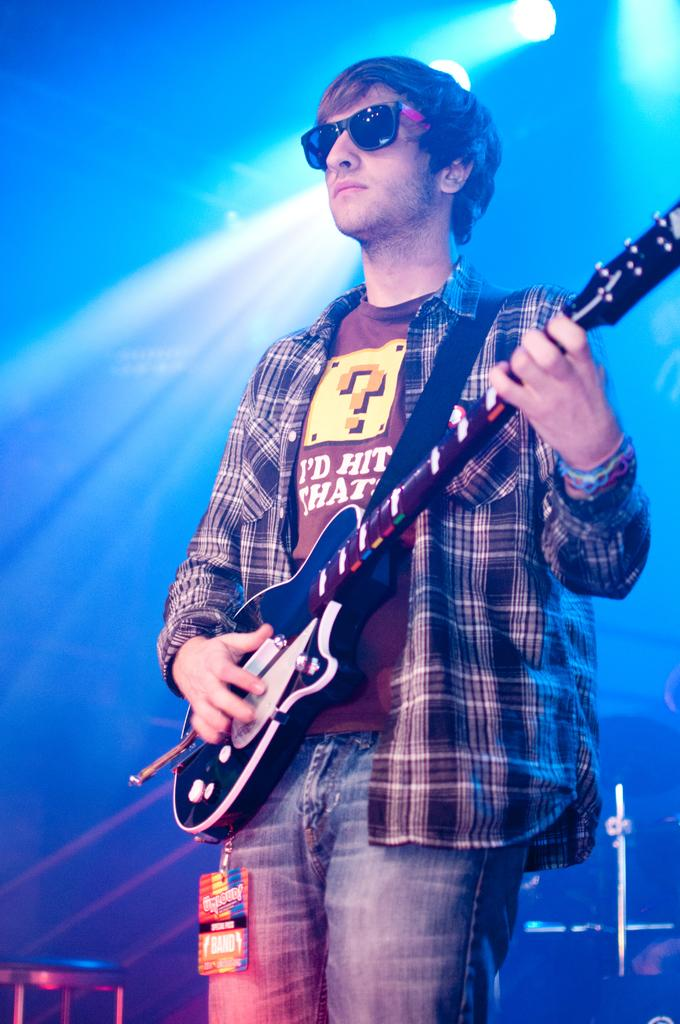What is the main subject of the image? There is a person in the image. What is the person doing in the image? The person is standing in the image. What object is the person holding? The person is holding a guitar in the image. What accessory is the person wearing? The person is wearing black color goggles in the image. What form of identification is visible on the person? The person has an id card in the image. Can you see a key hanging from the person's neck in the image? No, there is no key visible in the image. Is there a zebra standing next to the person in the image? No, there is no zebra present in the image. 